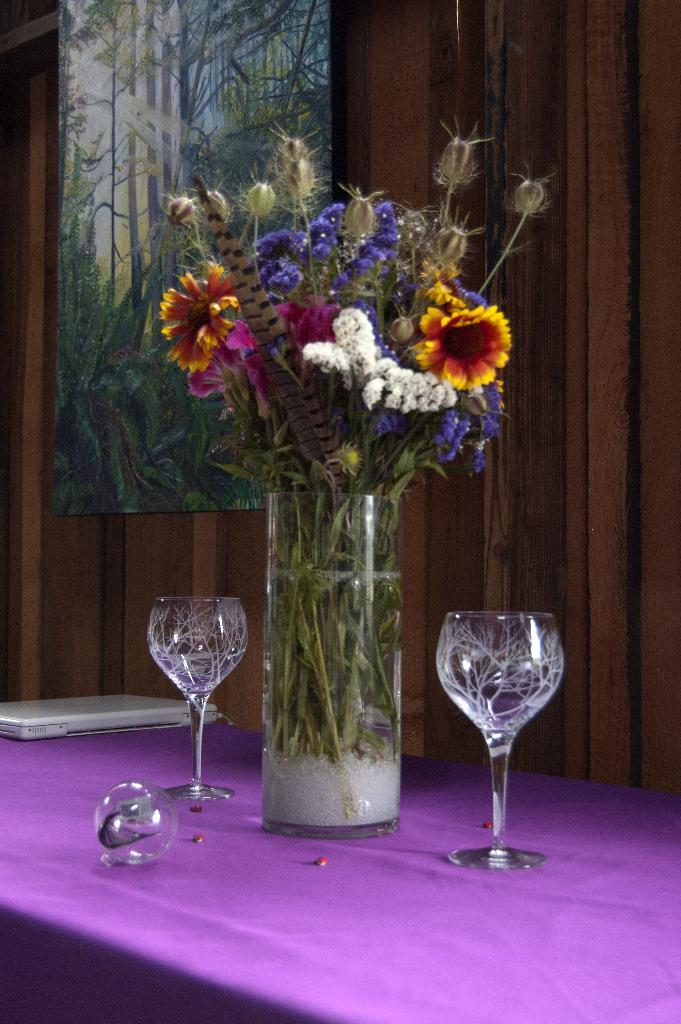What is inside the glass that is visible in the image? There are flowers in a glass in the image. How many glasses are on the table in the image? There are two glasses on a table in the image. What can be seen in the background of the image? There is a wall and a frame in the background of the image. What is depicted in the frame? The frame contains an image of trees and plants. How many bricks are visible in the image? There are no bricks visible in the image. What type of trucks can be seen in the image? There are no trucks present in the image. 